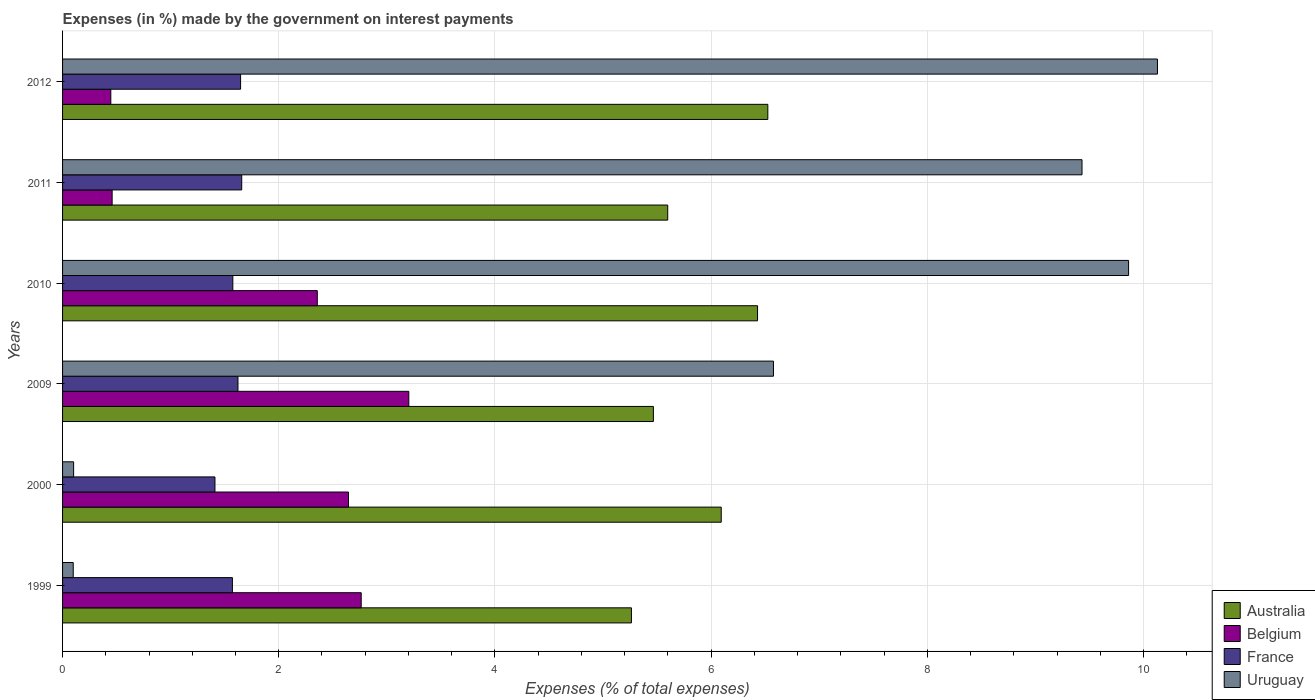How many groups of bars are there?
Your response must be concise. 6. Are the number of bars per tick equal to the number of legend labels?
Keep it short and to the point. Yes. Are the number of bars on each tick of the Y-axis equal?
Offer a terse response. Yes. How many bars are there on the 2nd tick from the top?
Your answer should be very brief. 4. What is the label of the 4th group of bars from the top?
Keep it short and to the point. 2009. What is the percentage of expenses made by the government on interest payments in Australia in 2000?
Your response must be concise. 6.09. Across all years, what is the maximum percentage of expenses made by the government on interest payments in Belgium?
Provide a succinct answer. 3.2. Across all years, what is the minimum percentage of expenses made by the government on interest payments in France?
Ensure brevity in your answer.  1.41. In which year was the percentage of expenses made by the government on interest payments in Belgium maximum?
Ensure brevity in your answer.  2009. In which year was the percentage of expenses made by the government on interest payments in Belgium minimum?
Your response must be concise. 2012. What is the total percentage of expenses made by the government on interest payments in Belgium in the graph?
Your answer should be compact. 11.87. What is the difference between the percentage of expenses made by the government on interest payments in France in 2000 and that in 2009?
Your response must be concise. -0.21. What is the difference between the percentage of expenses made by the government on interest payments in France in 2010 and the percentage of expenses made by the government on interest payments in Australia in 1999?
Ensure brevity in your answer.  -3.69. What is the average percentage of expenses made by the government on interest payments in France per year?
Provide a short and direct response. 1.58. In the year 2000, what is the difference between the percentage of expenses made by the government on interest payments in Belgium and percentage of expenses made by the government on interest payments in Australia?
Provide a succinct answer. -3.45. In how many years, is the percentage of expenses made by the government on interest payments in Belgium greater than 6.4 %?
Offer a terse response. 0. What is the ratio of the percentage of expenses made by the government on interest payments in Australia in 2009 to that in 2011?
Keep it short and to the point. 0.98. What is the difference between the highest and the second highest percentage of expenses made by the government on interest payments in Belgium?
Offer a very short reply. 0.44. What is the difference between the highest and the lowest percentage of expenses made by the government on interest payments in Australia?
Make the answer very short. 1.26. In how many years, is the percentage of expenses made by the government on interest payments in Australia greater than the average percentage of expenses made by the government on interest payments in Australia taken over all years?
Your answer should be very brief. 3. Is the sum of the percentage of expenses made by the government on interest payments in Belgium in 2000 and 2010 greater than the maximum percentage of expenses made by the government on interest payments in France across all years?
Your response must be concise. Yes. What does the 4th bar from the top in 2009 represents?
Your answer should be very brief. Australia. How many years are there in the graph?
Provide a short and direct response. 6. Does the graph contain any zero values?
Give a very brief answer. No. Does the graph contain grids?
Your answer should be compact. Yes. Where does the legend appear in the graph?
Your answer should be compact. Bottom right. What is the title of the graph?
Your answer should be compact. Expenses (in %) made by the government on interest payments. What is the label or title of the X-axis?
Your response must be concise. Expenses (% of total expenses). What is the label or title of the Y-axis?
Provide a short and direct response. Years. What is the Expenses (% of total expenses) of Australia in 1999?
Keep it short and to the point. 5.26. What is the Expenses (% of total expenses) of Belgium in 1999?
Give a very brief answer. 2.76. What is the Expenses (% of total expenses) of France in 1999?
Make the answer very short. 1.57. What is the Expenses (% of total expenses) of Uruguay in 1999?
Your answer should be very brief. 0.1. What is the Expenses (% of total expenses) in Australia in 2000?
Offer a very short reply. 6.09. What is the Expenses (% of total expenses) of Belgium in 2000?
Provide a short and direct response. 2.65. What is the Expenses (% of total expenses) of France in 2000?
Make the answer very short. 1.41. What is the Expenses (% of total expenses) in Uruguay in 2000?
Provide a short and direct response. 0.1. What is the Expenses (% of total expenses) in Australia in 2009?
Your answer should be very brief. 5.47. What is the Expenses (% of total expenses) of Belgium in 2009?
Provide a short and direct response. 3.2. What is the Expenses (% of total expenses) of France in 2009?
Offer a terse response. 1.62. What is the Expenses (% of total expenses) of Uruguay in 2009?
Your answer should be very brief. 6.58. What is the Expenses (% of total expenses) in Australia in 2010?
Give a very brief answer. 6.43. What is the Expenses (% of total expenses) of Belgium in 2010?
Offer a very short reply. 2.36. What is the Expenses (% of total expenses) of France in 2010?
Give a very brief answer. 1.58. What is the Expenses (% of total expenses) of Uruguay in 2010?
Provide a short and direct response. 9.86. What is the Expenses (% of total expenses) of Australia in 2011?
Make the answer very short. 5.6. What is the Expenses (% of total expenses) of Belgium in 2011?
Your answer should be compact. 0.46. What is the Expenses (% of total expenses) of France in 2011?
Provide a succinct answer. 1.66. What is the Expenses (% of total expenses) of Uruguay in 2011?
Your answer should be very brief. 9.43. What is the Expenses (% of total expenses) in Australia in 2012?
Offer a terse response. 6.52. What is the Expenses (% of total expenses) of Belgium in 2012?
Your response must be concise. 0.45. What is the Expenses (% of total expenses) of France in 2012?
Make the answer very short. 1.65. What is the Expenses (% of total expenses) in Uruguay in 2012?
Provide a short and direct response. 10.13. Across all years, what is the maximum Expenses (% of total expenses) of Australia?
Give a very brief answer. 6.52. Across all years, what is the maximum Expenses (% of total expenses) in Belgium?
Your response must be concise. 3.2. Across all years, what is the maximum Expenses (% of total expenses) of France?
Ensure brevity in your answer.  1.66. Across all years, what is the maximum Expenses (% of total expenses) in Uruguay?
Offer a very short reply. 10.13. Across all years, what is the minimum Expenses (% of total expenses) in Australia?
Your answer should be compact. 5.26. Across all years, what is the minimum Expenses (% of total expenses) in Belgium?
Ensure brevity in your answer.  0.45. Across all years, what is the minimum Expenses (% of total expenses) of France?
Your answer should be compact. 1.41. Across all years, what is the minimum Expenses (% of total expenses) of Uruguay?
Provide a succinct answer. 0.1. What is the total Expenses (% of total expenses) in Australia in the graph?
Provide a short and direct response. 35.37. What is the total Expenses (% of total expenses) of Belgium in the graph?
Offer a terse response. 11.87. What is the total Expenses (% of total expenses) in France in the graph?
Provide a short and direct response. 9.48. What is the total Expenses (% of total expenses) in Uruguay in the graph?
Offer a very short reply. 36.2. What is the difference between the Expenses (% of total expenses) in Australia in 1999 and that in 2000?
Offer a very short reply. -0.83. What is the difference between the Expenses (% of total expenses) in Belgium in 1999 and that in 2000?
Your response must be concise. 0.12. What is the difference between the Expenses (% of total expenses) in France in 1999 and that in 2000?
Give a very brief answer. 0.16. What is the difference between the Expenses (% of total expenses) in Uruguay in 1999 and that in 2000?
Give a very brief answer. -0. What is the difference between the Expenses (% of total expenses) of Australia in 1999 and that in 2009?
Your answer should be very brief. -0.2. What is the difference between the Expenses (% of total expenses) of Belgium in 1999 and that in 2009?
Keep it short and to the point. -0.44. What is the difference between the Expenses (% of total expenses) in France in 1999 and that in 2009?
Your response must be concise. -0.05. What is the difference between the Expenses (% of total expenses) of Uruguay in 1999 and that in 2009?
Make the answer very short. -6.48. What is the difference between the Expenses (% of total expenses) in Australia in 1999 and that in 2010?
Give a very brief answer. -1.17. What is the difference between the Expenses (% of total expenses) of Belgium in 1999 and that in 2010?
Give a very brief answer. 0.41. What is the difference between the Expenses (% of total expenses) of France in 1999 and that in 2010?
Ensure brevity in your answer.  -0. What is the difference between the Expenses (% of total expenses) of Uruguay in 1999 and that in 2010?
Your answer should be very brief. -9.76. What is the difference between the Expenses (% of total expenses) in Australia in 1999 and that in 2011?
Make the answer very short. -0.34. What is the difference between the Expenses (% of total expenses) in Belgium in 1999 and that in 2011?
Keep it short and to the point. 2.3. What is the difference between the Expenses (% of total expenses) of France in 1999 and that in 2011?
Keep it short and to the point. -0.09. What is the difference between the Expenses (% of total expenses) of Uruguay in 1999 and that in 2011?
Your answer should be very brief. -9.33. What is the difference between the Expenses (% of total expenses) of Australia in 1999 and that in 2012?
Offer a very short reply. -1.26. What is the difference between the Expenses (% of total expenses) of Belgium in 1999 and that in 2012?
Offer a terse response. 2.32. What is the difference between the Expenses (% of total expenses) in France in 1999 and that in 2012?
Provide a succinct answer. -0.08. What is the difference between the Expenses (% of total expenses) in Uruguay in 1999 and that in 2012?
Ensure brevity in your answer.  -10.03. What is the difference between the Expenses (% of total expenses) in Australia in 2000 and that in 2009?
Provide a short and direct response. 0.63. What is the difference between the Expenses (% of total expenses) of Belgium in 2000 and that in 2009?
Your answer should be very brief. -0.56. What is the difference between the Expenses (% of total expenses) of France in 2000 and that in 2009?
Your response must be concise. -0.21. What is the difference between the Expenses (% of total expenses) of Uruguay in 2000 and that in 2009?
Your answer should be compact. -6.47. What is the difference between the Expenses (% of total expenses) in Australia in 2000 and that in 2010?
Your response must be concise. -0.34. What is the difference between the Expenses (% of total expenses) of Belgium in 2000 and that in 2010?
Give a very brief answer. 0.29. What is the difference between the Expenses (% of total expenses) in France in 2000 and that in 2010?
Offer a terse response. -0.17. What is the difference between the Expenses (% of total expenses) of Uruguay in 2000 and that in 2010?
Your answer should be compact. -9.76. What is the difference between the Expenses (% of total expenses) in Australia in 2000 and that in 2011?
Your answer should be very brief. 0.5. What is the difference between the Expenses (% of total expenses) in Belgium in 2000 and that in 2011?
Offer a very short reply. 2.19. What is the difference between the Expenses (% of total expenses) of France in 2000 and that in 2011?
Your answer should be very brief. -0.25. What is the difference between the Expenses (% of total expenses) in Uruguay in 2000 and that in 2011?
Provide a succinct answer. -9.33. What is the difference between the Expenses (% of total expenses) in Australia in 2000 and that in 2012?
Your answer should be very brief. -0.43. What is the difference between the Expenses (% of total expenses) of Belgium in 2000 and that in 2012?
Your answer should be compact. 2.2. What is the difference between the Expenses (% of total expenses) of France in 2000 and that in 2012?
Offer a terse response. -0.24. What is the difference between the Expenses (% of total expenses) in Uruguay in 2000 and that in 2012?
Provide a succinct answer. -10.03. What is the difference between the Expenses (% of total expenses) of Australia in 2009 and that in 2010?
Your answer should be compact. -0.96. What is the difference between the Expenses (% of total expenses) in Belgium in 2009 and that in 2010?
Offer a very short reply. 0.85. What is the difference between the Expenses (% of total expenses) of France in 2009 and that in 2010?
Keep it short and to the point. 0.05. What is the difference between the Expenses (% of total expenses) in Uruguay in 2009 and that in 2010?
Your answer should be compact. -3.29. What is the difference between the Expenses (% of total expenses) of Australia in 2009 and that in 2011?
Provide a succinct answer. -0.13. What is the difference between the Expenses (% of total expenses) of Belgium in 2009 and that in 2011?
Your response must be concise. 2.74. What is the difference between the Expenses (% of total expenses) of France in 2009 and that in 2011?
Offer a terse response. -0.03. What is the difference between the Expenses (% of total expenses) in Uruguay in 2009 and that in 2011?
Make the answer very short. -2.85. What is the difference between the Expenses (% of total expenses) in Australia in 2009 and that in 2012?
Offer a very short reply. -1.06. What is the difference between the Expenses (% of total expenses) in Belgium in 2009 and that in 2012?
Your answer should be very brief. 2.76. What is the difference between the Expenses (% of total expenses) of France in 2009 and that in 2012?
Keep it short and to the point. -0.02. What is the difference between the Expenses (% of total expenses) in Uruguay in 2009 and that in 2012?
Offer a terse response. -3.55. What is the difference between the Expenses (% of total expenses) in Australia in 2010 and that in 2011?
Offer a terse response. 0.83. What is the difference between the Expenses (% of total expenses) in Belgium in 2010 and that in 2011?
Provide a short and direct response. 1.9. What is the difference between the Expenses (% of total expenses) in France in 2010 and that in 2011?
Your answer should be very brief. -0.08. What is the difference between the Expenses (% of total expenses) of Uruguay in 2010 and that in 2011?
Give a very brief answer. 0.43. What is the difference between the Expenses (% of total expenses) of Australia in 2010 and that in 2012?
Your answer should be compact. -0.1. What is the difference between the Expenses (% of total expenses) in Belgium in 2010 and that in 2012?
Keep it short and to the point. 1.91. What is the difference between the Expenses (% of total expenses) of France in 2010 and that in 2012?
Your answer should be very brief. -0.07. What is the difference between the Expenses (% of total expenses) of Uruguay in 2010 and that in 2012?
Provide a short and direct response. -0.27. What is the difference between the Expenses (% of total expenses) of Australia in 2011 and that in 2012?
Your answer should be very brief. -0.93. What is the difference between the Expenses (% of total expenses) in Belgium in 2011 and that in 2012?
Keep it short and to the point. 0.01. What is the difference between the Expenses (% of total expenses) in France in 2011 and that in 2012?
Offer a terse response. 0.01. What is the difference between the Expenses (% of total expenses) of Uruguay in 2011 and that in 2012?
Offer a very short reply. -0.7. What is the difference between the Expenses (% of total expenses) of Australia in 1999 and the Expenses (% of total expenses) of Belgium in 2000?
Give a very brief answer. 2.62. What is the difference between the Expenses (% of total expenses) in Australia in 1999 and the Expenses (% of total expenses) in France in 2000?
Ensure brevity in your answer.  3.85. What is the difference between the Expenses (% of total expenses) in Australia in 1999 and the Expenses (% of total expenses) in Uruguay in 2000?
Keep it short and to the point. 5.16. What is the difference between the Expenses (% of total expenses) of Belgium in 1999 and the Expenses (% of total expenses) of France in 2000?
Your response must be concise. 1.35. What is the difference between the Expenses (% of total expenses) in Belgium in 1999 and the Expenses (% of total expenses) in Uruguay in 2000?
Offer a terse response. 2.66. What is the difference between the Expenses (% of total expenses) of France in 1999 and the Expenses (% of total expenses) of Uruguay in 2000?
Your response must be concise. 1.47. What is the difference between the Expenses (% of total expenses) in Australia in 1999 and the Expenses (% of total expenses) in Belgium in 2009?
Your answer should be compact. 2.06. What is the difference between the Expenses (% of total expenses) in Australia in 1999 and the Expenses (% of total expenses) in France in 2009?
Ensure brevity in your answer.  3.64. What is the difference between the Expenses (% of total expenses) of Australia in 1999 and the Expenses (% of total expenses) of Uruguay in 2009?
Provide a short and direct response. -1.31. What is the difference between the Expenses (% of total expenses) in Belgium in 1999 and the Expenses (% of total expenses) in France in 2009?
Give a very brief answer. 1.14. What is the difference between the Expenses (% of total expenses) of Belgium in 1999 and the Expenses (% of total expenses) of Uruguay in 2009?
Provide a short and direct response. -3.81. What is the difference between the Expenses (% of total expenses) of France in 1999 and the Expenses (% of total expenses) of Uruguay in 2009?
Offer a very short reply. -5.01. What is the difference between the Expenses (% of total expenses) in Australia in 1999 and the Expenses (% of total expenses) in Belgium in 2010?
Provide a succinct answer. 2.91. What is the difference between the Expenses (% of total expenses) in Australia in 1999 and the Expenses (% of total expenses) in France in 2010?
Offer a terse response. 3.69. What is the difference between the Expenses (% of total expenses) of Australia in 1999 and the Expenses (% of total expenses) of Uruguay in 2010?
Your answer should be very brief. -4.6. What is the difference between the Expenses (% of total expenses) of Belgium in 1999 and the Expenses (% of total expenses) of France in 2010?
Your response must be concise. 1.19. What is the difference between the Expenses (% of total expenses) in Belgium in 1999 and the Expenses (% of total expenses) in Uruguay in 2010?
Your answer should be compact. -7.1. What is the difference between the Expenses (% of total expenses) of France in 1999 and the Expenses (% of total expenses) of Uruguay in 2010?
Your answer should be very brief. -8.29. What is the difference between the Expenses (% of total expenses) in Australia in 1999 and the Expenses (% of total expenses) in Belgium in 2011?
Offer a very short reply. 4.8. What is the difference between the Expenses (% of total expenses) in Australia in 1999 and the Expenses (% of total expenses) in France in 2011?
Ensure brevity in your answer.  3.61. What is the difference between the Expenses (% of total expenses) of Australia in 1999 and the Expenses (% of total expenses) of Uruguay in 2011?
Your response must be concise. -4.17. What is the difference between the Expenses (% of total expenses) of Belgium in 1999 and the Expenses (% of total expenses) of France in 2011?
Keep it short and to the point. 1.11. What is the difference between the Expenses (% of total expenses) in Belgium in 1999 and the Expenses (% of total expenses) in Uruguay in 2011?
Your answer should be very brief. -6.67. What is the difference between the Expenses (% of total expenses) in France in 1999 and the Expenses (% of total expenses) in Uruguay in 2011?
Provide a succinct answer. -7.86. What is the difference between the Expenses (% of total expenses) in Australia in 1999 and the Expenses (% of total expenses) in Belgium in 2012?
Your answer should be very brief. 4.82. What is the difference between the Expenses (% of total expenses) in Australia in 1999 and the Expenses (% of total expenses) in France in 2012?
Offer a terse response. 3.62. What is the difference between the Expenses (% of total expenses) in Australia in 1999 and the Expenses (% of total expenses) in Uruguay in 2012?
Offer a terse response. -4.87. What is the difference between the Expenses (% of total expenses) in Belgium in 1999 and the Expenses (% of total expenses) in France in 2012?
Ensure brevity in your answer.  1.12. What is the difference between the Expenses (% of total expenses) of Belgium in 1999 and the Expenses (% of total expenses) of Uruguay in 2012?
Offer a terse response. -7.37. What is the difference between the Expenses (% of total expenses) of France in 1999 and the Expenses (% of total expenses) of Uruguay in 2012?
Offer a very short reply. -8.56. What is the difference between the Expenses (% of total expenses) in Australia in 2000 and the Expenses (% of total expenses) in Belgium in 2009?
Your answer should be very brief. 2.89. What is the difference between the Expenses (% of total expenses) of Australia in 2000 and the Expenses (% of total expenses) of France in 2009?
Provide a short and direct response. 4.47. What is the difference between the Expenses (% of total expenses) in Australia in 2000 and the Expenses (% of total expenses) in Uruguay in 2009?
Your answer should be very brief. -0.48. What is the difference between the Expenses (% of total expenses) in Belgium in 2000 and the Expenses (% of total expenses) in France in 2009?
Ensure brevity in your answer.  1.02. What is the difference between the Expenses (% of total expenses) of Belgium in 2000 and the Expenses (% of total expenses) of Uruguay in 2009?
Offer a very short reply. -3.93. What is the difference between the Expenses (% of total expenses) in France in 2000 and the Expenses (% of total expenses) in Uruguay in 2009?
Offer a very short reply. -5.17. What is the difference between the Expenses (% of total expenses) in Australia in 2000 and the Expenses (% of total expenses) in Belgium in 2010?
Your answer should be compact. 3.74. What is the difference between the Expenses (% of total expenses) of Australia in 2000 and the Expenses (% of total expenses) of France in 2010?
Your answer should be compact. 4.52. What is the difference between the Expenses (% of total expenses) in Australia in 2000 and the Expenses (% of total expenses) in Uruguay in 2010?
Your answer should be very brief. -3.77. What is the difference between the Expenses (% of total expenses) in Belgium in 2000 and the Expenses (% of total expenses) in France in 2010?
Offer a terse response. 1.07. What is the difference between the Expenses (% of total expenses) of Belgium in 2000 and the Expenses (% of total expenses) of Uruguay in 2010?
Keep it short and to the point. -7.22. What is the difference between the Expenses (% of total expenses) in France in 2000 and the Expenses (% of total expenses) in Uruguay in 2010?
Provide a short and direct response. -8.45. What is the difference between the Expenses (% of total expenses) in Australia in 2000 and the Expenses (% of total expenses) in Belgium in 2011?
Keep it short and to the point. 5.63. What is the difference between the Expenses (% of total expenses) of Australia in 2000 and the Expenses (% of total expenses) of France in 2011?
Provide a succinct answer. 4.44. What is the difference between the Expenses (% of total expenses) of Australia in 2000 and the Expenses (% of total expenses) of Uruguay in 2011?
Ensure brevity in your answer.  -3.34. What is the difference between the Expenses (% of total expenses) in Belgium in 2000 and the Expenses (% of total expenses) in Uruguay in 2011?
Keep it short and to the point. -6.79. What is the difference between the Expenses (% of total expenses) in France in 2000 and the Expenses (% of total expenses) in Uruguay in 2011?
Provide a succinct answer. -8.02. What is the difference between the Expenses (% of total expenses) of Australia in 2000 and the Expenses (% of total expenses) of Belgium in 2012?
Provide a succinct answer. 5.65. What is the difference between the Expenses (% of total expenses) in Australia in 2000 and the Expenses (% of total expenses) in France in 2012?
Your answer should be very brief. 4.45. What is the difference between the Expenses (% of total expenses) of Australia in 2000 and the Expenses (% of total expenses) of Uruguay in 2012?
Make the answer very short. -4.04. What is the difference between the Expenses (% of total expenses) of Belgium in 2000 and the Expenses (% of total expenses) of France in 2012?
Your response must be concise. 1. What is the difference between the Expenses (% of total expenses) in Belgium in 2000 and the Expenses (% of total expenses) in Uruguay in 2012?
Make the answer very short. -7.48. What is the difference between the Expenses (% of total expenses) in France in 2000 and the Expenses (% of total expenses) in Uruguay in 2012?
Provide a short and direct response. -8.72. What is the difference between the Expenses (% of total expenses) in Australia in 2009 and the Expenses (% of total expenses) in Belgium in 2010?
Your answer should be very brief. 3.11. What is the difference between the Expenses (% of total expenses) in Australia in 2009 and the Expenses (% of total expenses) in France in 2010?
Ensure brevity in your answer.  3.89. What is the difference between the Expenses (% of total expenses) of Australia in 2009 and the Expenses (% of total expenses) of Uruguay in 2010?
Give a very brief answer. -4.4. What is the difference between the Expenses (% of total expenses) of Belgium in 2009 and the Expenses (% of total expenses) of France in 2010?
Offer a very short reply. 1.63. What is the difference between the Expenses (% of total expenses) in Belgium in 2009 and the Expenses (% of total expenses) in Uruguay in 2010?
Offer a terse response. -6.66. What is the difference between the Expenses (% of total expenses) in France in 2009 and the Expenses (% of total expenses) in Uruguay in 2010?
Your answer should be very brief. -8.24. What is the difference between the Expenses (% of total expenses) of Australia in 2009 and the Expenses (% of total expenses) of Belgium in 2011?
Give a very brief answer. 5.01. What is the difference between the Expenses (% of total expenses) in Australia in 2009 and the Expenses (% of total expenses) in France in 2011?
Keep it short and to the point. 3.81. What is the difference between the Expenses (% of total expenses) of Australia in 2009 and the Expenses (% of total expenses) of Uruguay in 2011?
Keep it short and to the point. -3.97. What is the difference between the Expenses (% of total expenses) of Belgium in 2009 and the Expenses (% of total expenses) of France in 2011?
Offer a terse response. 1.55. What is the difference between the Expenses (% of total expenses) of Belgium in 2009 and the Expenses (% of total expenses) of Uruguay in 2011?
Your answer should be very brief. -6.23. What is the difference between the Expenses (% of total expenses) of France in 2009 and the Expenses (% of total expenses) of Uruguay in 2011?
Your answer should be compact. -7.81. What is the difference between the Expenses (% of total expenses) of Australia in 2009 and the Expenses (% of total expenses) of Belgium in 2012?
Provide a succinct answer. 5.02. What is the difference between the Expenses (% of total expenses) in Australia in 2009 and the Expenses (% of total expenses) in France in 2012?
Offer a very short reply. 3.82. What is the difference between the Expenses (% of total expenses) in Australia in 2009 and the Expenses (% of total expenses) in Uruguay in 2012?
Keep it short and to the point. -4.66. What is the difference between the Expenses (% of total expenses) of Belgium in 2009 and the Expenses (% of total expenses) of France in 2012?
Give a very brief answer. 1.56. What is the difference between the Expenses (% of total expenses) in Belgium in 2009 and the Expenses (% of total expenses) in Uruguay in 2012?
Your answer should be compact. -6.93. What is the difference between the Expenses (% of total expenses) in France in 2009 and the Expenses (% of total expenses) in Uruguay in 2012?
Offer a very short reply. -8.51. What is the difference between the Expenses (% of total expenses) of Australia in 2010 and the Expenses (% of total expenses) of Belgium in 2011?
Provide a short and direct response. 5.97. What is the difference between the Expenses (% of total expenses) of Australia in 2010 and the Expenses (% of total expenses) of France in 2011?
Provide a succinct answer. 4.77. What is the difference between the Expenses (% of total expenses) in Australia in 2010 and the Expenses (% of total expenses) in Uruguay in 2011?
Offer a very short reply. -3. What is the difference between the Expenses (% of total expenses) in Belgium in 2010 and the Expenses (% of total expenses) in France in 2011?
Ensure brevity in your answer.  0.7. What is the difference between the Expenses (% of total expenses) in Belgium in 2010 and the Expenses (% of total expenses) in Uruguay in 2011?
Your answer should be very brief. -7.07. What is the difference between the Expenses (% of total expenses) of France in 2010 and the Expenses (% of total expenses) of Uruguay in 2011?
Keep it short and to the point. -7.86. What is the difference between the Expenses (% of total expenses) in Australia in 2010 and the Expenses (% of total expenses) in Belgium in 2012?
Offer a terse response. 5.98. What is the difference between the Expenses (% of total expenses) of Australia in 2010 and the Expenses (% of total expenses) of France in 2012?
Give a very brief answer. 4.78. What is the difference between the Expenses (% of total expenses) of Australia in 2010 and the Expenses (% of total expenses) of Uruguay in 2012?
Make the answer very short. -3.7. What is the difference between the Expenses (% of total expenses) in Belgium in 2010 and the Expenses (% of total expenses) in France in 2012?
Give a very brief answer. 0.71. What is the difference between the Expenses (% of total expenses) in Belgium in 2010 and the Expenses (% of total expenses) in Uruguay in 2012?
Provide a short and direct response. -7.77. What is the difference between the Expenses (% of total expenses) in France in 2010 and the Expenses (% of total expenses) in Uruguay in 2012?
Provide a succinct answer. -8.55. What is the difference between the Expenses (% of total expenses) of Australia in 2011 and the Expenses (% of total expenses) of Belgium in 2012?
Your answer should be compact. 5.15. What is the difference between the Expenses (% of total expenses) in Australia in 2011 and the Expenses (% of total expenses) in France in 2012?
Make the answer very short. 3.95. What is the difference between the Expenses (% of total expenses) in Australia in 2011 and the Expenses (% of total expenses) in Uruguay in 2012?
Your answer should be very brief. -4.53. What is the difference between the Expenses (% of total expenses) in Belgium in 2011 and the Expenses (% of total expenses) in France in 2012?
Make the answer very short. -1.19. What is the difference between the Expenses (% of total expenses) of Belgium in 2011 and the Expenses (% of total expenses) of Uruguay in 2012?
Make the answer very short. -9.67. What is the difference between the Expenses (% of total expenses) of France in 2011 and the Expenses (% of total expenses) of Uruguay in 2012?
Your response must be concise. -8.47. What is the average Expenses (% of total expenses) in Australia per year?
Make the answer very short. 5.9. What is the average Expenses (% of total expenses) in Belgium per year?
Make the answer very short. 1.98. What is the average Expenses (% of total expenses) in France per year?
Make the answer very short. 1.58. What is the average Expenses (% of total expenses) in Uruguay per year?
Offer a very short reply. 6.03. In the year 1999, what is the difference between the Expenses (% of total expenses) of Australia and Expenses (% of total expenses) of Belgium?
Your response must be concise. 2.5. In the year 1999, what is the difference between the Expenses (% of total expenses) of Australia and Expenses (% of total expenses) of France?
Offer a terse response. 3.69. In the year 1999, what is the difference between the Expenses (% of total expenses) in Australia and Expenses (% of total expenses) in Uruguay?
Your response must be concise. 5.16. In the year 1999, what is the difference between the Expenses (% of total expenses) of Belgium and Expenses (% of total expenses) of France?
Offer a terse response. 1.19. In the year 1999, what is the difference between the Expenses (% of total expenses) in Belgium and Expenses (% of total expenses) in Uruguay?
Your answer should be compact. 2.66. In the year 1999, what is the difference between the Expenses (% of total expenses) in France and Expenses (% of total expenses) in Uruguay?
Keep it short and to the point. 1.47. In the year 2000, what is the difference between the Expenses (% of total expenses) of Australia and Expenses (% of total expenses) of Belgium?
Make the answer very short. 3.45. In the year 2000, what is the difference between the Expenses (% of total expenses) of Australia and Expenses (% of total expenses) of France?
Give a very brief answer. 4.68. In the year 2000, what is the difference between the Expenses (% of total expenses) in Australia and Expenses (% of total expenses) in Uruguay?
Your answer should be very brief. 5.99. In the year 2000, what is the difference between the Expenses (% of total expenses) of Belgium and Expenses (% of total expenses) of France?
Offer a terse response. 1.24. In the year 2000, what is the difference between the Expenses (% of total expenses) of Belgium and Expenses (% of total expenses) of Uruguay?
Your response must be concise. 2.54. In the year 2000, what is the difference between the Expenses (% of total expenses) in France and Expenses (% of total expenses) in Uruguay?
Make the answer very short. 1.31. In the year 2009, what is the difference between the Expenses (% of total expenses) in Australia and Expenses (% of total expenses) in Belgium?
Provide a short and direct response. 2.26. In the year 2009, what is the difference between the Expenses (% of total expenses) of Australia and Expenses (% of total expenses) of France?
Ensure brevity in your answer.  3.84. In the year 2009, what is the difference between the Expenses (% of total expenses) of Australia and Expenses (% of total expenses) of Uruguay?
Make the answer very short. -1.11. In the year 2009, what is the difference between the Expenses (% of total expenses) of Belgium and Expenses (% of total expenses) of France?
Offer a very short reply. 1.58. In the year 2009, what is the difference between the Expenses (% of total expenses) of Belgium and Expenses (% of total expenses) of Uruguay?
Make the answer very short. -3.37. In the year 2009, what is the difference between the Expenses (% of total expenses) of France and Expenses (% of total expenses) of Uruguay?
Keep it short and to the point. -4.95. In the year 2010, what is the difference between the Expenses (% of total expenses) in Australia and Expenses (% of total expenses) in Belgium?
Provide a short and direct response. 4.07. In the year 2010, what is the difference between the Expenses (% of total expenses) of Australia and Expenses (% of total expenses) of France?
Give a very brief answer. 4.85. In the year 2010, what is the difference between the Expenses (% of total expenses) in Australia and Expenses (% of total expenses) in Uruguay?
Your answer should be very brief. -3.43. In the year 2010, what is the difference between the Expenses (% of total expenses) in Belgium and Expenses (% of total expenses) in France?
Your answer should be compact. 0.78. In the year 2010, what is the difference between the Expenses (% of total expenses) in Belgium and Expenses (% of total expenses) in Uruguay?
Offer a terse response. -7.51. In the year 2010, what is the difference between the Expenses (% of total expenses) of France and Expenses (% of total expenses) of Uruguay?
Offer a terse response. -8.29. In the year 2011, what is the difference between the Expenses (% of total expenses) of Australia and Expenses (% of total expenses) of Belgium?
Your answer should be compact. 5.14. In the year 2011, what is the difference between the Expenses (% of total expenses) in Australia and Expenses (% of total expenses) in France?
Your answer should be very brief. 3.94. In the year 2011, what is the difference between the Expenses (% of total expenses) in Australia and Expenses (% of total expenses) in Uruguay?
Your response must be concise. -3.83. In the year 2011, what is the difference between the Expenses (% of total expenses) of Belgium and Expenses (% of total expenses) of France?
Your response must be concise. -1.2. In the year 2011, what is the difference between the Expenses (% of total expenses) of Belgium and Expenses (% of total expenses) of Uruguay?
Your answer should be very brief. -8.97. In the year 2011, what is the difference between the Expenses (% of total expenses) of France and Expenses (% of total expenses) of Uruguay?
Provide a succinct answer. -7.77. In the year 2012, what is the difference between the Expenses (% of total expenses) in Australia and Expenses (% of total expenses) in Belgium?
Provide a succinct answer. 6.08. In the year 2012, what is the difference between the Expenses (% of total expenses) of Australia and Expenses (% of total expenses) of France?
Your answer should be very brief. 4.88. In the year 2012, what is the difference between the Expenses (% of total expenses) of Australia and Expenses (% of total expenses) of Uruguay?
Your answer should be very brief. -3.6. In the year 2012, what is the difference between the Expenses (% of total expenses) of Belgium and Expenses (% of total expenses) of France?
Your answer should be very brief. -1.2. In the year 2012, what is the difference between the Expenses (% of total expenses) of Belgium and Expenses (% of total expenses) of Uruguay?
Provide a succinct answer. -9.68. In the year 2012, what is the difference between the Expenses (% of total expenses) in France and Expenses (% of total expenses) in Uruguay?
Give a very brief answer. -8.48. What is the ratio of the Expenses (% of total expenses) of Australia in 1999 to that in 2000?
Your answer should be compact. 0.86. What is the ratio of the Expenses (% of total expenses) of Belgium in 1999 to that in 2000?
Make the answer very short. 1.04. What is the ratio of the Expenses (% of total expenses) in France in 1999 to that in 2000?
Make the answer very short. 1.11. What is the ratio of the Expenses (% of total expenses) in Uruguay in 1999 to that in 2000?
Your response must be concise. 0.97. What is the ratio of the Expenses (% of total expenses) of Australia in 1999 to that in 2009?
Keep it short and to the point. 0.96. What is the ratio of the Expenses (% of total expenses) of Belgium in 1999 to that in 2009?
Offer a very short reply. 0.86. What is the ratio of the Expenses (% of total expenses) in France in 1999 to that in 2009?
Ensure brevity in your answer.  0.97. What is the ratio of the Expenses (% of total expenses) of Uruguay in 1999 to that in 2009?
Provide a succinct answer. 0.01. What is the ratio of the Expenses (% of total expenses) of Australia in 1999 to that in 2010?
Make the answer very short. 0.82. What is the ratio of the Expenses (% of total expenses) of Belgium in 1999 to that in 2010?
Make the answer very short. 1.17. What is the ratio of the Expenses (% of total expenses) of Uruguay in 1999 to that in 2010?
Your answer should be compact. 0.01. What is the ratio of the Expenses (% of total expenses) in Australia in 1999 to that in 2011?
Your answer should be very brief. 0.94. What is the ratio of the Expenses (% of total expenses) of Belgium in 1999 to that in 2011?
Offer a terse response. 6.02. What is the ratio of the Expenses (% of total expenses) in France in 1999 to that in 2011?
Your response must be concise. 0.95. What is the ratio of the Expenses (% of total expenses) of Uruguay in 1999 to that in 2011?
Offer a terse response. 0.01. What is the ratio of the Expenses (% of total expenses) of Australia in 1999 to that in 2012?
Offer a very short reply. 0.81. What is the ratio of the Expenses (% of total expenses) in Belgium in 1999 to that in 2012?
Offer a terse response. 6.19. What is the ratio of the Expenses (% of total expenses) in France in 1999 to that in 2012?
Ensure brevity in your answer.  0.95. What is the ratio of the Expenses (% of total expenses) in Uruguay in 1999 to that in 2012?
Offer a very short reply. 0.01. What is the ratio of the Expenses (% of total expenses) of Australia in 2000 to that in 2009?
Provide a succinct answer. 1.11. What is the ratio of the Expenses (% of total expenses) of Belgium in 2000 to that in 2009?
Offer a very short reply. 0.83. What is the ratio of the Expenses (% of total expenses) in France in 2000 to that in 2009?
Give a very brief answer. 0.87. What is the ratio of the Expenses (% of total expenses) in Uruguay in 2000 to that in 2009?
Give a very brief answer. 0.02. What is the ratio of the Expenses (% of total expenses) of Australia in 2000 to that in 2010?
Offer a terse response. 0.95. What is the ratio of the Expenses (% of total expenses) of Belgium in 2000 to that in 2010?
Give a very brief answer. 1.12. What is the ratio of the Expenses (% of total expenses) of France in 2000 to that in 2010?
Ensure brevity in your answer.  0.9. What is the ratio of the Expenses (% of total expenses) in Uruguay in 2000 to that in 2010?
Ensure brevity in your answer.  0.01. What is the ratio of the Expenses (% of total expenses) in Australia in 2000 to that in 2011?
Make the answer very short. 1.09. What is the ratio of the Expenses (% of total expenses) of Belgium in 2000 to that in 2011?
Your response must be concise. 5.77. What is the ratio of the Expenses (% of total expenses) of France in 2000 to that in 2011?
Your answer should be compact. 0.85. What is the ratio of the Expenses (% of total expenses) in Uruguay in 2000 to that in 2011?
Ensure brevity in your answer.  0.01. What is the ratio of the Expenses (% of total expenses) in Australia in 2000 to that in 2012?
Provide a succinct answer. 0.93. What is the ratio of the Expenses (% of total expenses) in Belgium in 2000 to that in 2012?
Offer a very short reply. 5.93. What is the ratio of the Expenses (% of total expenses) in France in 2000 to that in 2012?
Offer a very short reply. 0.86. What is the ratio of the Expenses (% of total expenses) of Uruguay in 2000 to that in 2012?
Provide a short and direct response. 0.01. What is the ratio of the Expenses (% of total expenses) of Australia in 2009 to that in 2010?
Offer a very short reply. 0.85. What is the ratio of the Expenses (% of total expenses) of Belgium in 2009 to that in 2010?
Your answer should be compact. 1.36. What is the ratio of the Expenses (% of total expenses) in France in 2009 to that in 2010?
Your response must be concise. 1.03. What is the ratio of the Expenses (% of total expenses) in Uruguay in 2009 to that in 2010?
Give a very brief answer. 0.67. What is the ratio of the Expenses (% of total expenses) in Australia in 2009 to that in 2011?
Offer a very short reply. 0.98. What is the ratio of the Expenses (% of total expenses) of Belgium in 2009 to that in 2011?
Your answer should be compact. 6.98. What is the ratio of the Expenses (% of total expenses) in France in 2009 to that in 2011?
Your answer should be compact. 0.98. What is the ratio of the Expenses (% of total expenses) in Uruguay in 2009 to that in 2011?
Provide a short and direct response. 0.7. What is the ratio of the Expenses (% of total expenses) in Australia in 2009 to that in 2012?
Give a very brief answer. 0.84. What is the ratio of the Expenses (% of total expenses) in Belgium in 2009 to that in 2012?
Your answer should be very brief. 7.18. What is the ratio of the Expenses (% of total expenses) in Uruguay in 2009 to that in 2012?
Offer a terse response. 0.65. What is the ratio of the Expenses (% of total expenses) in Australia in 2010 to that in 2011?
Ensure brevity in your answer.  1.15. What is the ratio of the Expenses (% of total expenses) of Belgium in 2010 to that in 2011?
Keep it short and to the point. 5.14. What is the ratio of the Expenses (% of total expenses) in France in 2010 to that in 2011?
Your answer should be compact. 0.95. What is the ratio of the Expenses (% of total expenses) of Uruguay in 2010 to that in 2011?
Keep it short and to the point. 1.05. What is the ratio of the Expenses (% of total expenses) of Australia in 2010 to that in 2012?
Your answer should be very brief. 0.99. What is the ratio of the Expenses (% of total expenses) in Belgium in 2010 to that in 2012?
Ensure brevity in your answer.  5.28. What is the ratio of the Expenses (% of total expenses) in France in 2010 to that in 2012?
Ensure brevity in your answer.  0.96. What is the ratio of the Expenses (% of total expenses) in Uruguay in 2010 to that in 2012?
Your answer should be very brief. 0.97. What is the ratio of the Expenses (% of total expenses) of Australia in 2011 to that in 2012?
Your response must be concise. 0.86. What is the ratio of the Expenses (% of total expenses) of Belgium in 2011 to that in 2012?
Your answer should be very brief. 1.03. What is the ratio of the Expenses (% of total expenses) in Uruguay in 2011 to that in 2012?
Your answer should be very brief. 0.93. What is the difference between the highest and the second highest Expenses (% of total expenses) in Australia?
Offer a very short reply. 0.1. What is the difference between the highest and the second highest Expenses (% of total expenses) of Belgium?
Your response must be concise. 0.44. What is the difference between the highest and the second highest Expenses (% of total expenses) of France?
Offer a terse response. 0.01. What is the difference between the highest and the second highest Expenses (% of total expenses) of Uruguay?
Give a very brief answer. 0.27. What is the difference between the highest and the lowest Expenses (% of total expenses) in Australia?
Provide a succinct answer. 1.26. What is the difference between the highest and the lowest Expenses (% of total expenses) in Belgium?
Ensure brevity in your answer.  2.76. What is the difference between the highest and the lowest Expenses (% of total expenses) of France?
Keep it short and to the point. 0.25. What is the difference between the highest and the lowest Expenses (% of total expenses) in Uruguay?
Make the answer very short. 10.03. 